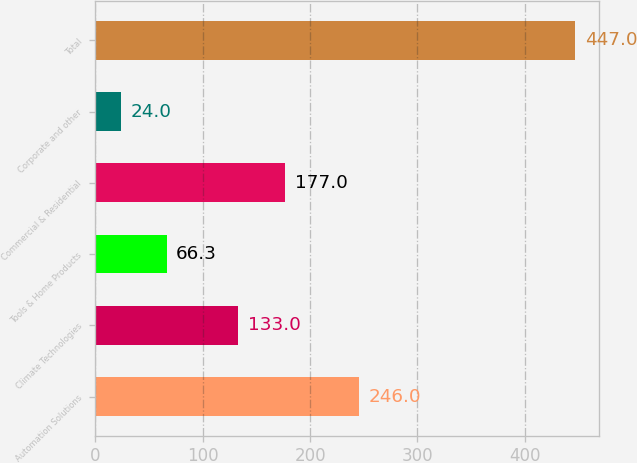Convert chart to OTSL. <chart><loc_0><loc_0><loc_500><loc_500><bar_chart><fcel>Automation Solutions<fcel>Climate Technologies<fcel>Tools & Home Products<fcel>Commercial & Residential<fcel>Corporate and other<fcel>Total<nl><fcel>246<fcel>133<fcel>66.3<fcel>177<fcel>24<fcel>447<nl></chart> 